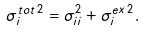<formula> <loc_0><loc_0><loc_500><loc_500>\sigma ^ { t o t \, 2 } _ { i } = \sigma ^ { 2 } _ { i i } + \sigma ^ { e x \, 2 } _ { i } .</formula> 